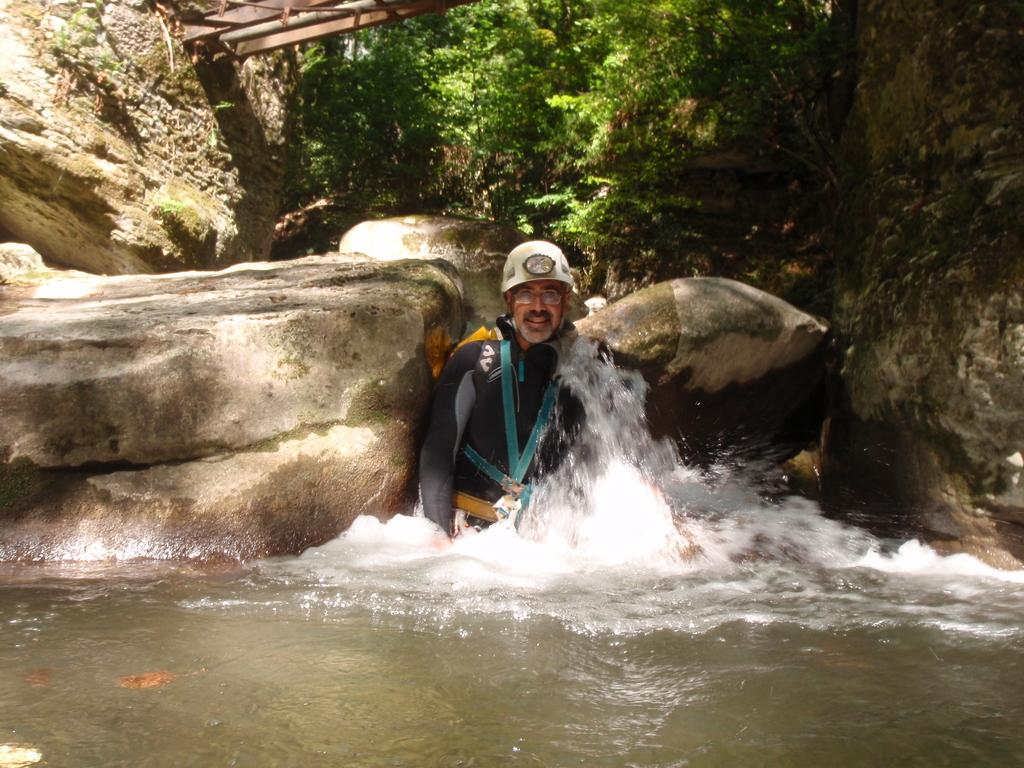What is the main subject of the image? There is a person standing in the image. Where is the person located? The person is standing in water. What can be seen behind the person? There are rocks behind the person. What type of natural environment is visible in the image? There are trees visible in the image. What type of sugar is being used to sweeten the water in the image? There is no sugar present in the image, and the water is not being sweetened. How many snakes can be seen slithering around the person in the image? There are no snakes present in the image; the person is standing in water with rocks and trees visible in the background. 